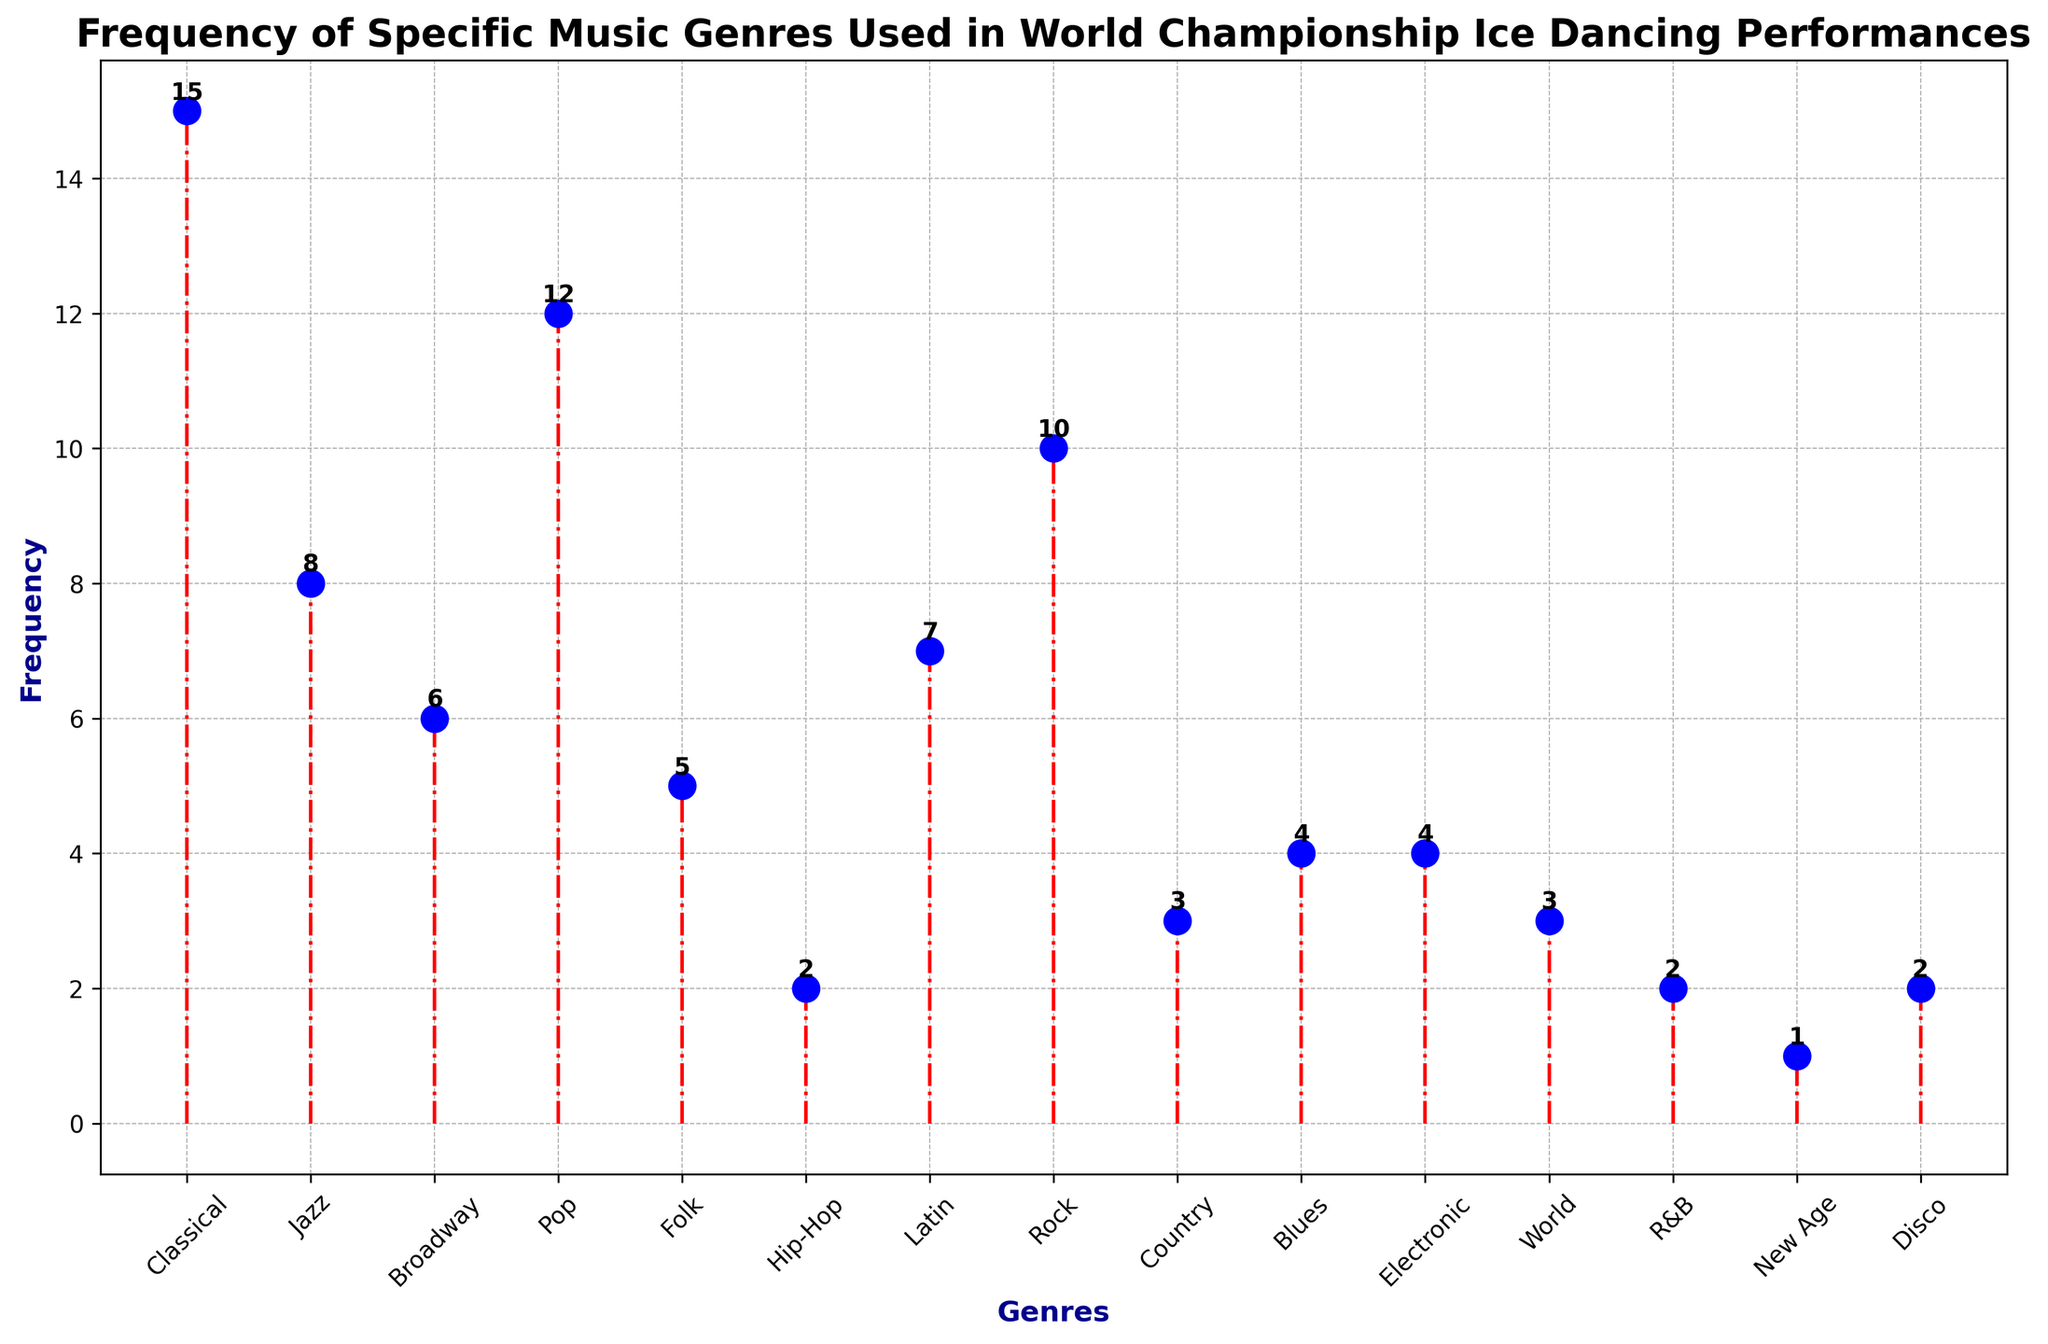What are the three most frequently used music genres in World Championship Ice Dancing Performances? To find this, identify the three highest frequencies in the plot. The genres corresponding to these frequencies are the ones we are looking for. Classical (15), Pop (12), and Rock (10) are the top three.
Answer: Classical, Pop, Rock Which genre is used more frequently, Jazz or Folk? Compare the frequencies of Jazz (8) and Folk (5) by looking at their corresponding stem lengths. Since 8 is greater than 5, Jazz is used more frequently than Folk.
Answer: Jazz What is the difference in frequency between the most and least frequently used genres? The most frequently used genre is Classical with a frequency of 15, and the least frequently used genre is New Age with a frequency of 1. Subtract 1 from 15 to find the difference.
Answer: 14 How many music genres have a frequency of 4? Observe the stem lengths corresponding to the frequency of 4. There are three genres that meet this criterion: Blues, Electronic, and World.
Answer: 3 What is the combined frequency of Latin, Rock, and Country genres? Look at the frequencies for these genres: Latin (7), Rock (10), Country (3). Sum these values: 7 + 10 + 3.
Answer: 20 Which music genre has the same frequency as Blues and Electronic combined? First, sum the frequencies of Blues (4) and Electronic (4), which equals 8. Identify the genre that also has a frequency of 8, which is Jazz.
Answer: Jazz Are there more genres with a frequency greater than 7 or with a frequency less than 4? Count the number of genres with frequencies greater than 7 (Classical, Pop, Rock, Jazz, Broadway, Latin; total: 5) and fewer than 4 (Country, World, New Age, R&B, Disco, Hip-Hop; total: 6). Since 6 is greater than 5, there are more genres with a frequency less than 4.
Answer: Less than 4 Which genre is used equally as frequently as Disco? Observe the stem for Disco, which has a frequency of 2. Identify another genre with the same frequency, which is Hip-Hop and R&B.
Answer: Hip-Hop, R&B 